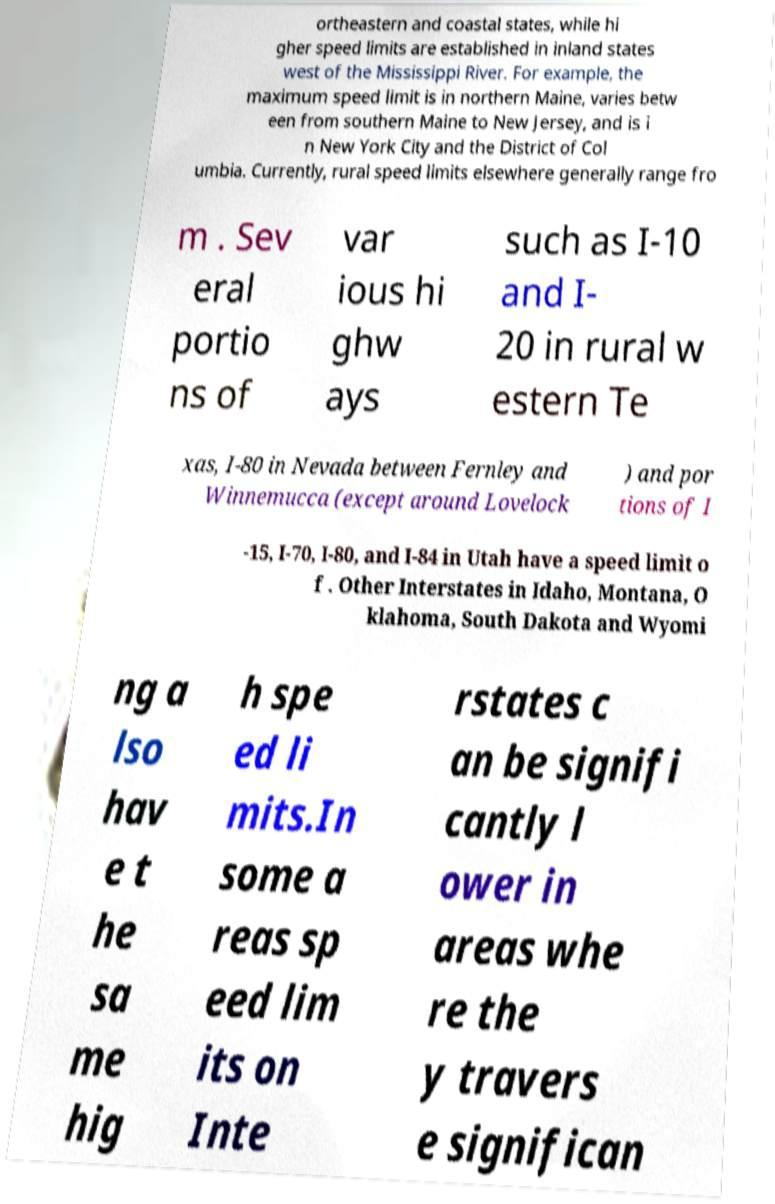Could you assist in decoding the text presented in this image and type it out clearly? ortheastern and coastal states, while hi gher speed limits are established in inland states west of the Mississippi River. For example, the maximum speed limit is in northern Maine, varies betw een from southern Maine to New Jersey, and is i n New York City and the District of Col umbia. Currently, rural speed limits elsewhere generally range fro m . Sev eral portio ns of var ious hi ghw ays such as I-10 and I- 20 in rural w estern Te xas, I-80 in Nevada between Fernley and Winnemucca (except around Lovelock ) and por tions of I -15, I-70, I-80, and I-84 in Utah have a speed limit o f . Other Interstates in Idaho, Montana, O klahoma, South Dakota and Wyomi ng a lso hav e t he sa me hig h spe ed li mits.In some a reas sp eed lim its on Inte rstates c an be signifi cantly l ower in areas whe re the y travers e significan 